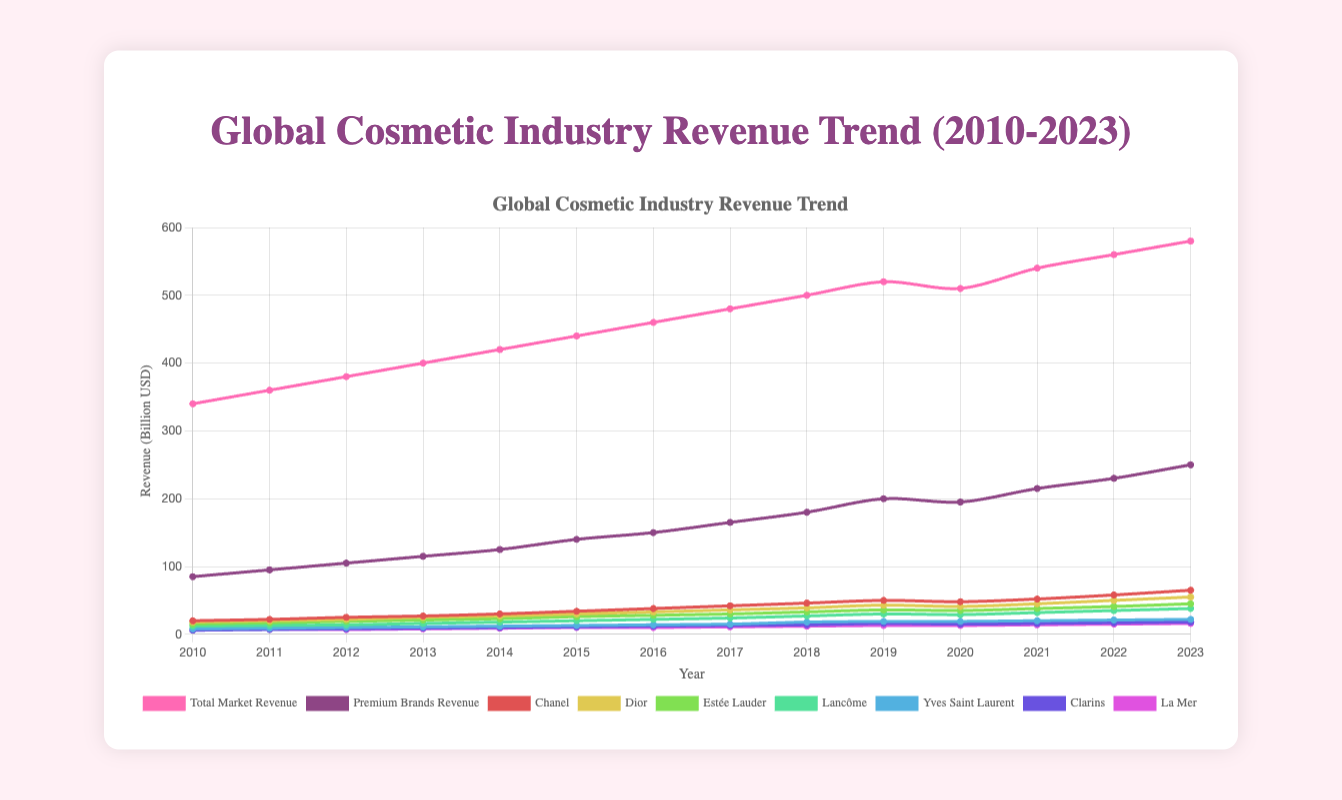Which brand had the highest revenue in 2023 among the premium brands? To determine the brand with the highest revenue in 2023, look at the endpoints of the lines corresponding to the premium brands for that year. The purple line for Chanel ends at 65, which is the highest value.
Answer: Chanel Compare the total market revenue and premium brands revenue in 2019. Which was higher and by how much? In 2019, the total market revenue was $520 billion, and the premium brands revenue was $200 billion. Subtract the two to find the difference: 520 - 200 = 320.
Answer: Total market by 320 billion What was the percentage increase in revenue for Estée Lauder from 2010 to 2023? In 2010, Estée Lauder's revenue was $15 billion, and in 2023, it was $45 billion. The percentage increase is calculated as ((45 - 15) / 15) * 100 = 200%.
Answer: 200% Which brand showed the largest revenue increase between 2021 and 2022? Compare the revenue values for each brand for the years 2021 and 2022. The largest increase is for Chanel, going from 52 billion to 58 billion, an increase of 6 billion.
Answer: Chanel Between 2010 and 2023, did the revenue for La Mer ever decline? Look at the trend line for La Mer from 2010 to 2023. The revenue shows a constant or increasing trend every year from 6 to 16 billion.
Answer: No Was the premium brands revenue growth rate higher than the total market revenue growth rate between 2010 and 2023? Calculate the growth rates: Premium Brands: (250-85)/85 = 1.94 (194% increase), Total Market: (580-340)/340 = 0.71 (71% increase). Premium brands growth rate is higher.
Answer: Yes During which year did the total market revenue experience its first decline since 2010? Observe the total market revenue trend line; the first decline occurs between 2019 (520) and 2020 (510).
Answer: 2020 For how many brands did revenues surpass $40 billion in 2023? Check the endpoints of each brand's trend line in 2023. Chanel (65 billion), Dior (55 billion), and Estée Lauder (45 billion) surpassed 40 billion, totaling 3 brands.
Answer: 3 brands Calculate the average revenue of Lancôme from 2010 to 2023. Sum the revenues for Lancôme: (12 + 13 + 14 + 16 + 18 + 20 + 22 + 24 + 27 + 30 + 29 + 32 + 35 + 38) = 330. There are 14 years, so the average is 330/14 ≈ 23.57.
Answer: 23.57 billion By what amount did the total revenue for premium brands surpass that of La Mer in 2023? Premium brands revenue in 2023 was 250 billion, and La Mer's revenue was 16 billion. The surplus amount is 250 - 16 = 234 billion.
Answer: 234 billion 